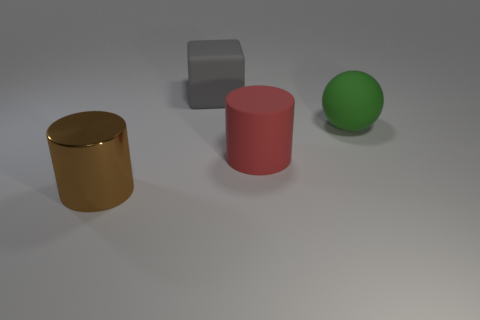Add 1 red rubber cylinders. How many objects exist? 5 Subtract all balls. How many objects are left? 3 Add 4 cyan shiny cubes. How many cyan shiny cubes exist? 4 Subtract 0 yellow cylinders. How many objects are left? 4 Subtract all rubber spheres. Subtract all large yellow cylinders. How many objects are left? 3 Add 4 big gray objects. How many big gray objects are left? 5 